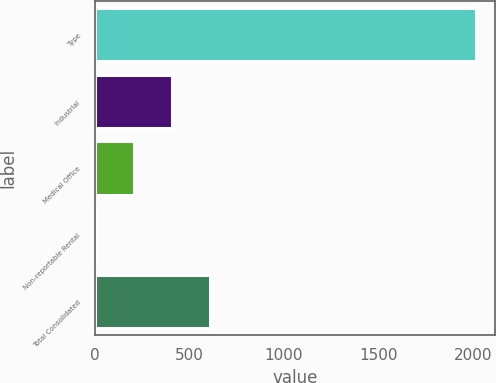Convert chart to OTSL. <chart><loc_0><loc_0><loc_500><loc_500><bar_chart><fcel>Type<fcel>Industrial<fcel>Medical Office<fcel>Non-reportable Rental<fcel>Total Consolidated<nl><fcel>2015<fcel>405.48<fcel>204.29<fcel>3.1<fcel>606.67<nl></chart> 